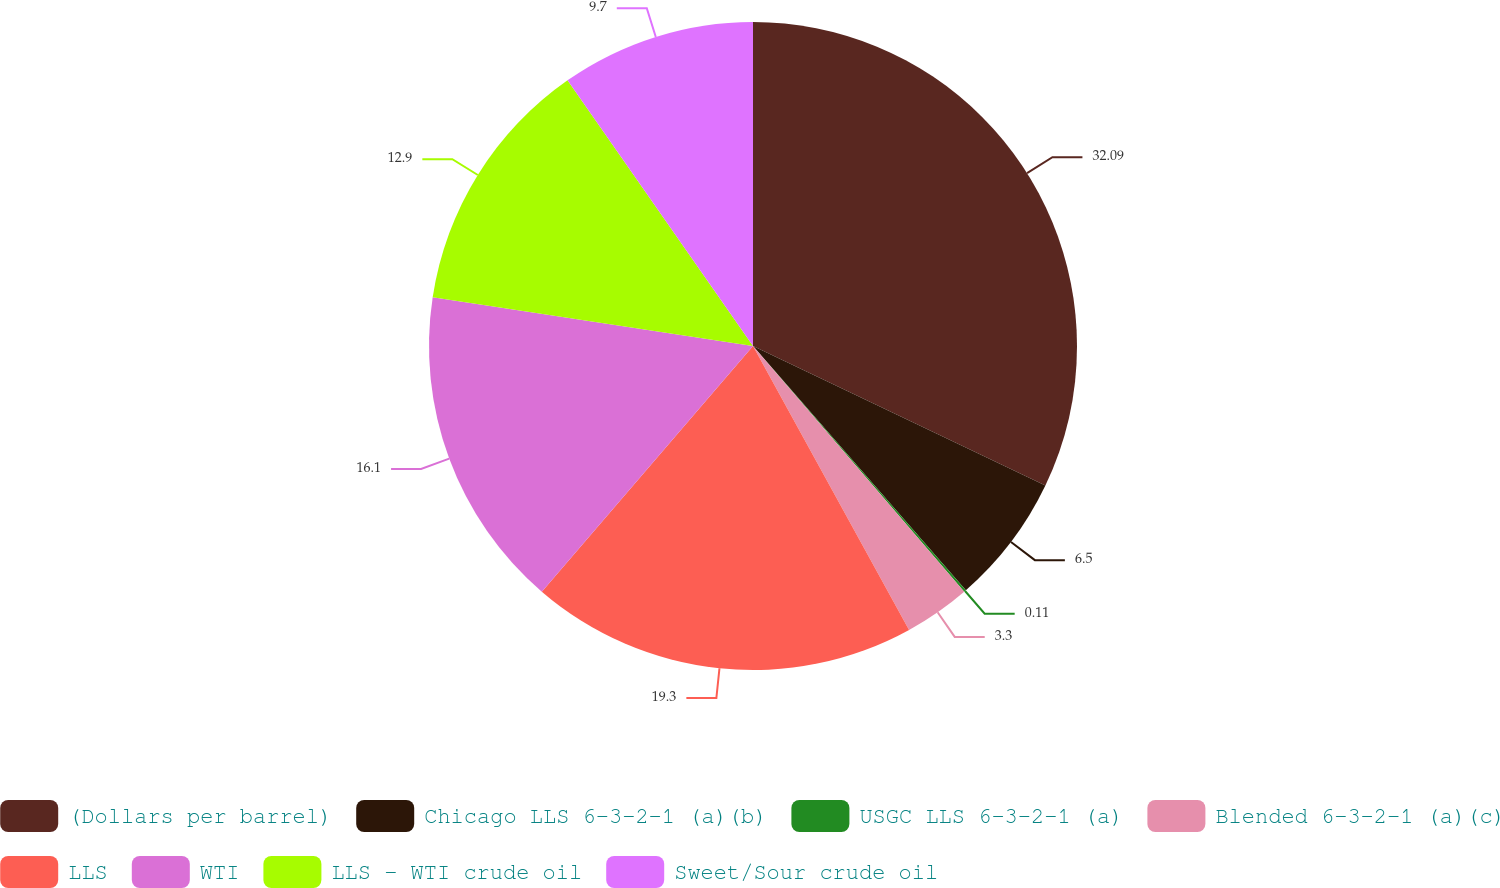<chart> <loc_0><loc_0><loc_500><loc_500><pie_chart><fcel>(Dollars per barrel)<fcel>Chicago LLS 6-3-2-1 (a)(b)<fcel>USGC LLS 6-3-2-1 (a)<fcel>Blended 6-3-2-1 (a)(c)<fcel>LLS<fcel>WTI<fcel>LLS - WTI crude oil<fcel>Sweet/Sour crude oil<nl><fcel>32.09%<fcel>6.5%<fcel>0.11%<fcel>3.3%<fcel>19.3%<fcel>16.1%<fcel>12.9%<fcel>9.7%<nl></chart> 